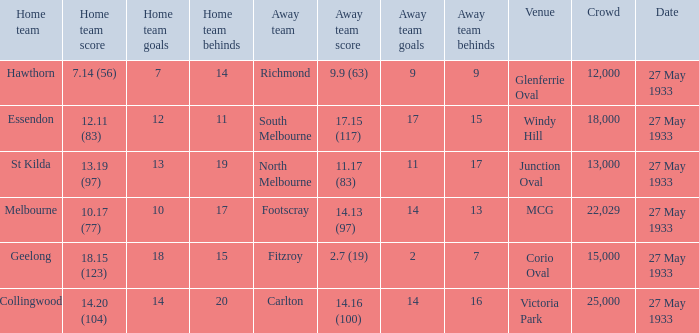Write the full table. {'header': ['Home team', 'Home team score', 'Home team goals', 'Home team behinds', 'Away team', 'Away team score', 'Away team goals', 'Away team behinds', 'Venue', 'Crowd', 'Date'], 'rows': [['Hawthorn', '7.14 (56)', '7', '14', 'Richmond', '9.9 (63)', '9', '9', 'Glenferrie Oval', '12,000', '27 May 1933'], ['Essendon', '12.11 (83)', '12', '11', 'South Melbourne', '17.15 (117)', '17', '15', 'Windy Hill', '18,000', '27 May 1933'], ['St Kilda', '13.19 (97)', '13', '19', 'North Melbourne', '11.17 (83)', '11', '17', 'Junction Oval', '13,000', '27 May 1933'], ['Melbourne', '10.17 (77)', '10', '17', 'Footscray', '14.13 (97)', '14', '13', 'MCG', '22,029', '27 May 1933'], ['Geelong', '18.15 (123)', '18', '15', 'Fitzroy', '2.7 (19)', '2', '7', 'Corio Oval', '15,000', '27 May 1933'], ['Collingwood', '14.20 (104)', '14', '20', 'Carlton', '14.16 (100)', '14', '16', 'Victoria Park', '25,000', '27 May 1933']]} In the match where the away team scored 2.7 (19), how many peopel were in the crowd? 15000.0. 